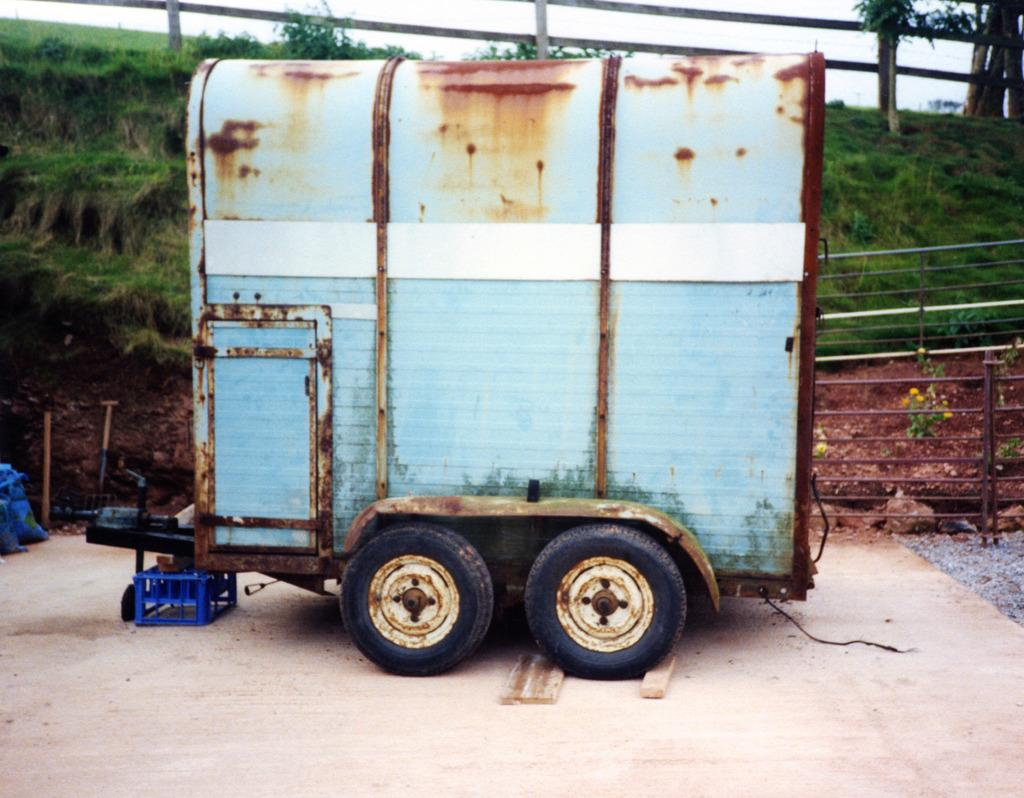What is the main subject in the image? There is a vehicle in the image. Where is the vehicle located in the image? The vehicle is at the front of the image. What type of natural environment can be seen in the background of the image? There is grass visible in the background of the image. How is the grass situated in the image? The grass is on the surface in the background. What color of paint is being used to decorate the trains in the image? There are no trains present in the image, and therefore no paint or decoration can be observed. 